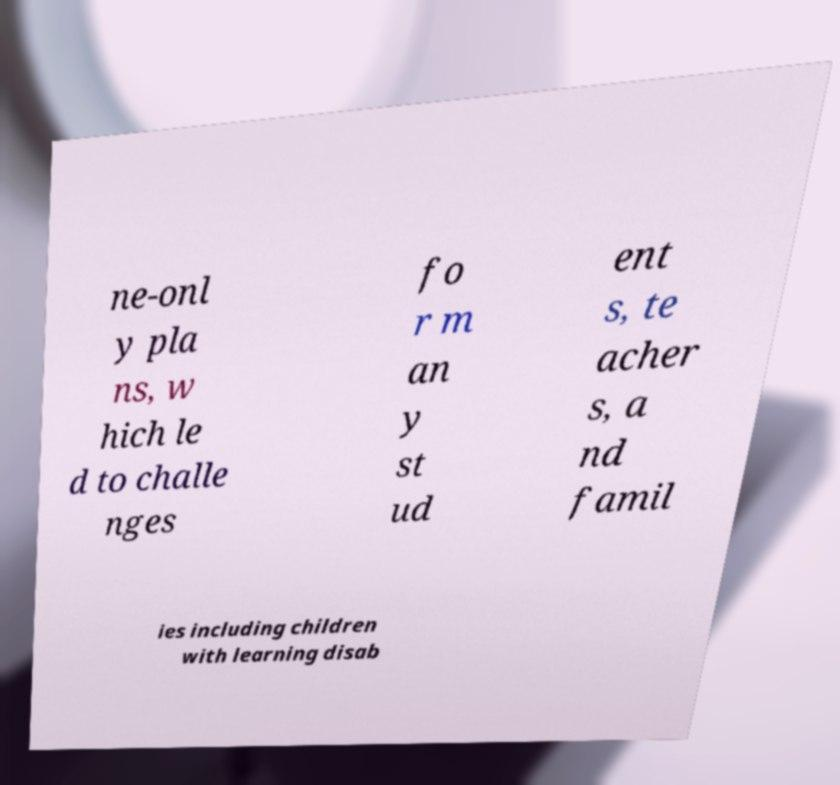Can you accurately transcribe the text from the provided image for me? ne-onl y pla ns, w hich le d to challe nges fo r m an y st ud ent s, te acher s, a nd famil ies including children with learning disab 